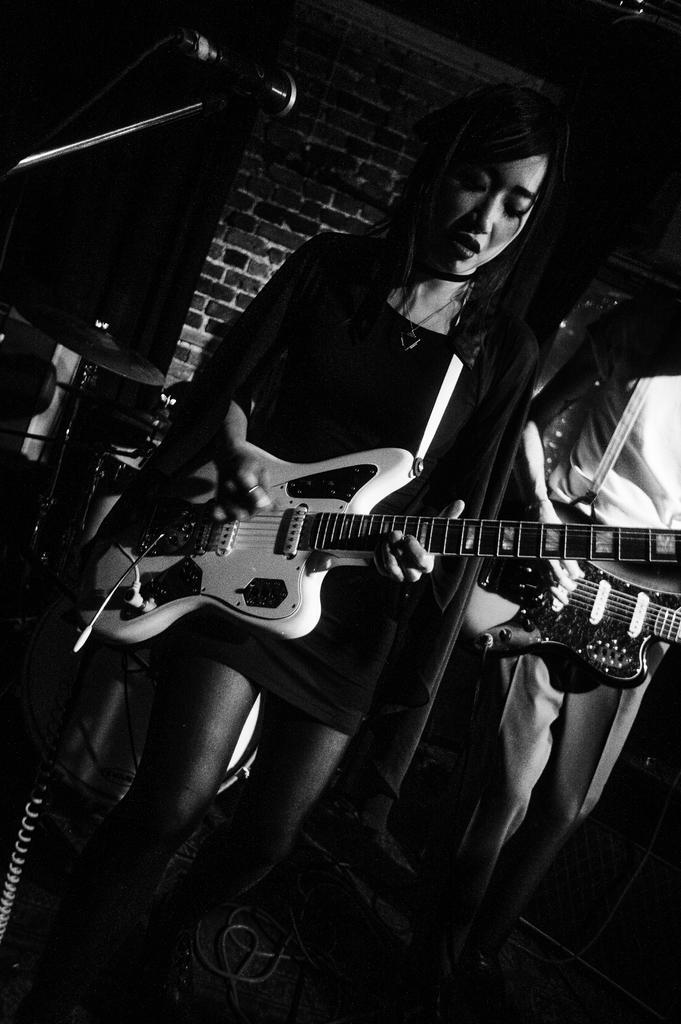Please provide a concise description of this image. In the image we can see a woman standing, wearing clothes, neck chain and she is holding a guitar in her hand. Beside her there is a person standing wearing clothes. This is a microphone, cable wire and a brick wall. 